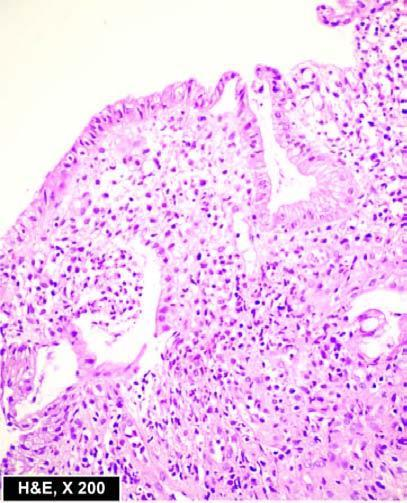re epithelial follicles superficial ulcerations, with mucosal infiltration by inflammatory cells and a 'crypt abscess '?
Answer the question using a single word or phrase. No 